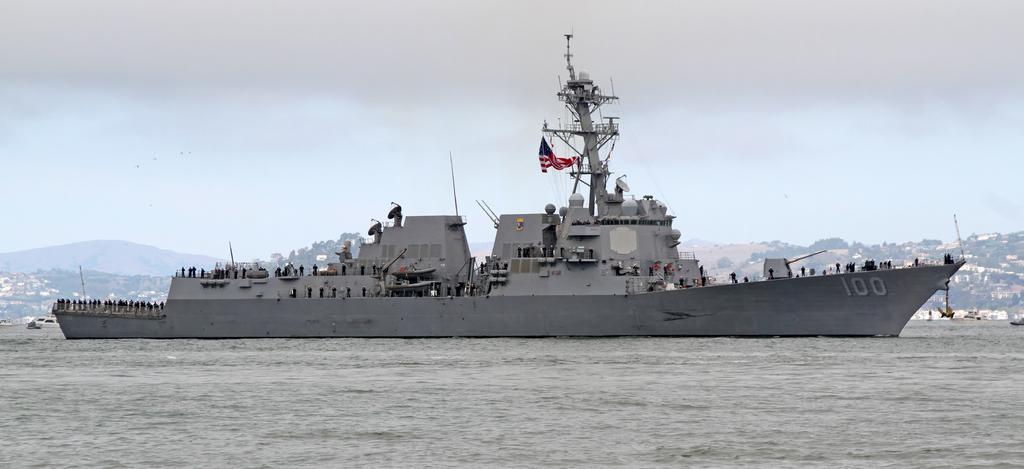Can you describe this image briefly? In this image in the front there is water. In the center there is a ship and on the ship there are persons, there are antennas and there is a tower and there is a flag. In the background there are trees, buildings and mountains and the sky is cloudy. 